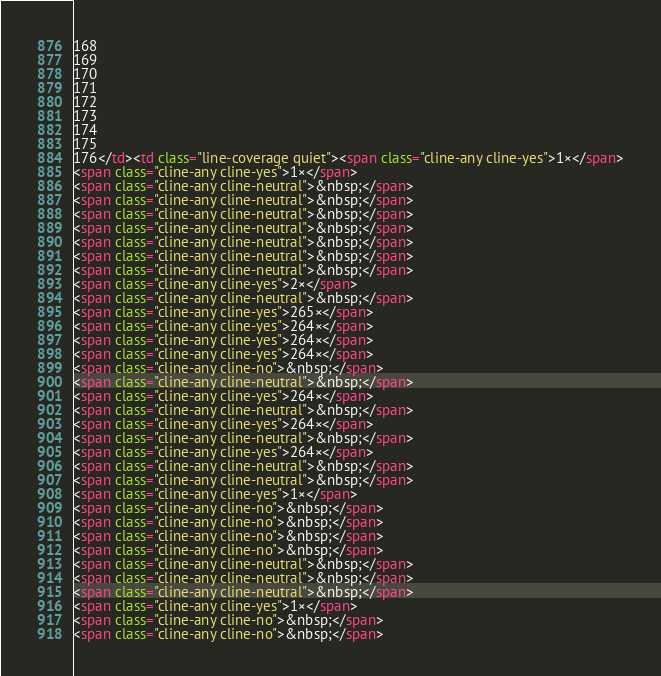<code> <loc_0><loc_0><loc_500><loc_500><_HTML_>168
169
170
171
172
173
174
175
176</td><td class="line-coverage quiet"><span class="cline-any cline-yes">1×</span>
<span class="cline-any cline-yes">1×</span>
<span class="cline-any cline-neutral">&nbsp;</span>
<span class="cline-any cline-neutral">&nbsp;</span>
<span class="cline-any cline-neutral">&nbsp;</span>
<span class="cline-any cline-neutral">&nbsp;</span>
<span class="cline-any cline-neutral">&nbsp;</span>
<span class="cline-any cline-neutral">&nbsp;</span>
<span class="cline-any cline-neutral">&nbsp;</span>
<span class="cline-any cline-yes">2×</span>
<span class="cline-any cline-neutral">&nbsp;</span>
<span class="cline-any cline-yes">265×</span>
<span class="cline-any cline-yes">264×</span>
<span class="cline-any cline-yes">264×</span>
<span class="cline-any cline-yes">264×</span>
<span class="cline-any cline-no">&nbsp;</span>
<span class="cline-any cline-neutral">&nbsp;</span>
<span class="cline-any cline-yes">264×</span>
<span class="cline-any cline-neutral">&nbsp;</span>
<span class="cline-any cline-yes">264×</span>
<span class="cline-any cline-neutral">&nbsp;</span>
<span class="cline-any cline-yes">264×</span>
<span class="cline-any cline-neutral">&nbsp;</span>
<span class="cline-any cline-neutral">&nbsp;</span>
<span class="cline-any cline-yes">1×</span>
<span class="cline-any cline-no">&nbsp;</span>
<span class="cline-any cline-no">&nbsp;</span>
<span class="cline-any cline-no">&nbsp;</span>
<span class="cline-any cline-no">&nbsp;</span>
<span class="cline-any cline-neutral">&nbsp;</span>
<span class="cline-any cline-neutral">&nbsp;</span>
<span class="cline-any cline-neutral">&nbsp;</span>
<span class="cline-any cline-yes">1×</span>
<span class="cline-any cline-no">&nbsp;</span>
<span class="cline-any cline-no">&nbsp;</span></code> 